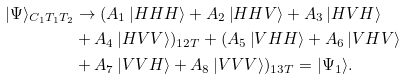Convert formula to latex. <formula><loc_0><loc_0><loc_500><loc_500>| \Psi \rangle _ { C _ { 1 } T _ { 1 } T _ { 2 } } & \rightarrow ( A _ { 1 } \left | H H H \right \rangle + A _ { 2 } \left | H H V \right \rangle + A _ { 3 } \left | H V H \right \rangle \\ & + A _ { 4 } \left | H V V \right \rangle ) _ { 1 2 T } + ( A _ { 5 } \left | V H H \right \rangle + A _ { 6 } \left | V H V \right \rangle \\ & + A _ { 7 } \left | V V H \right \rangle + A _ { 8 } \left | V V V \right \rangle ) _ { 1 3 T } = | \Psi _ { 1 } \rangle .</formula> 